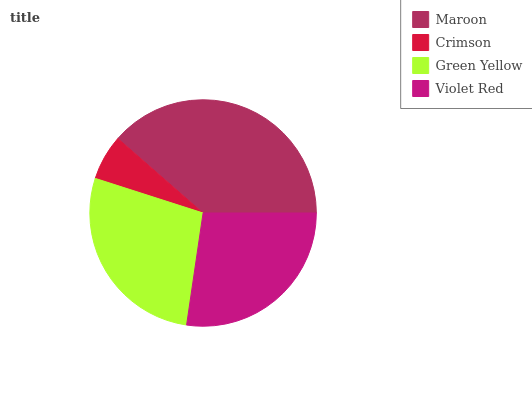Is Crimson the minimum?
Answer yes or no. Yes. Is Maroon the maximum?
Answer yes or no. Yes. Is Green Yellow the minimum?
Answer yes or no. No. Is Green Yellow the maximum?
Answer yes or no. No. Is Green Yellow greater than Crimson?
Answer yes or no. Yes. Is Crimson less than Green Yellow?
Answer yes or no. Yes. Is Crimson greater than Green Yellow?
Answer yes or no. No. Is Green Yellow less than Crimson?
Answer yes or no. No. Is Green Yellow the high median?
Answer yes or no. Yes. Is Violet Red the low median?
Answer yes or no. Yes. Is Maroon the high median?
Answer yes or no. No. Is Green Yellow the low median?
Answer yes or no. No. 